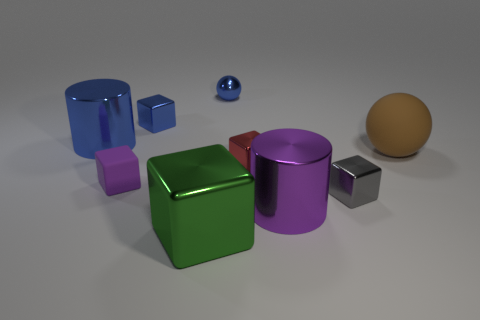Subtract all red blocks. Subtract all red cylinders. How many blocks are left? 4 Add 1 small gray things. How many objects exist? 10 Subtract all cubes. How many objects are left? 4 Add 2 small purple rubber things. How many small purple rubber things exist? 3 Subtract 0 yellow cylinders. How many objects are left? 9 Subtract all small gray shiny objects. Subtract all red cubes. How many objects are left? 7 Add 7 tiny gray cubes. How many tiny gray cubes are left? 8 